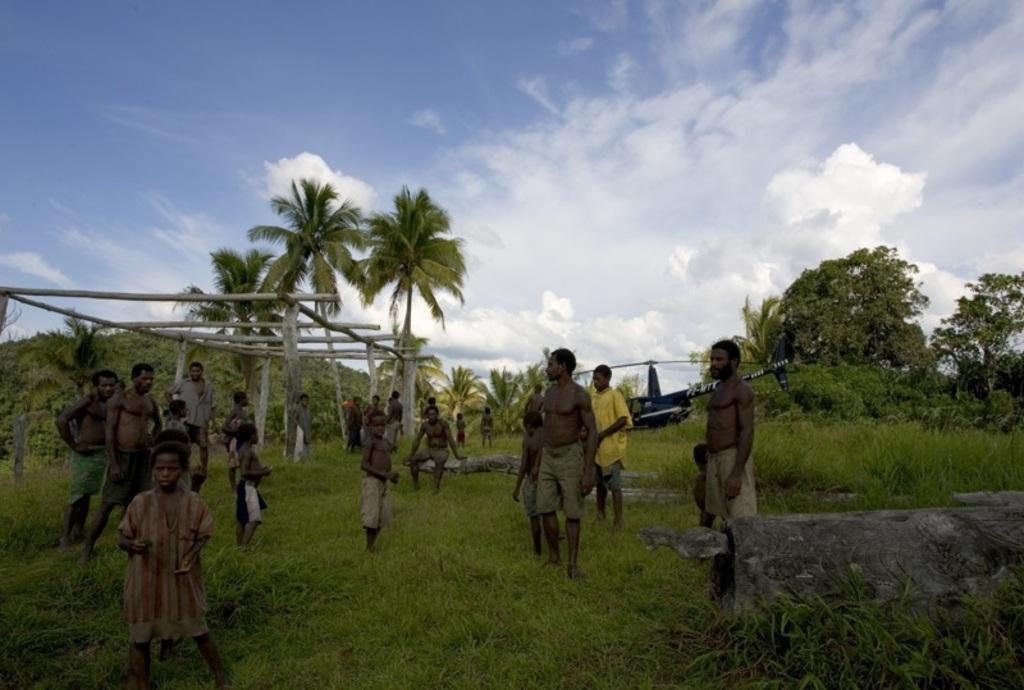In one or two sentences, can you explain what this image depicts? In the image there are few african men and kids standing on the grassland, in the back there is a helicopter and trees all over the place and above its sky with clouds. 